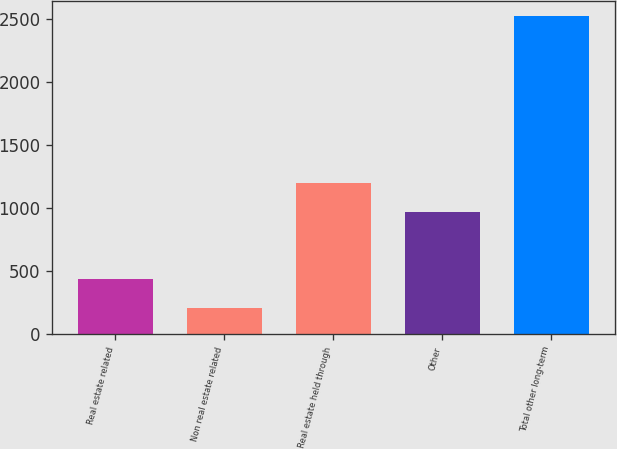Convert chart. <chart><loc_0><loc_0><loc_500><loc_500><bar_chart><fcel>Real estate related<fcel>Non real estate related<fcel>Real estate held through<fcel>Other<fcel>Total other long-term<nl><fcel>439<fcel>208<fcel>1200<fcel>969<fcel>2518<nl></chart> 